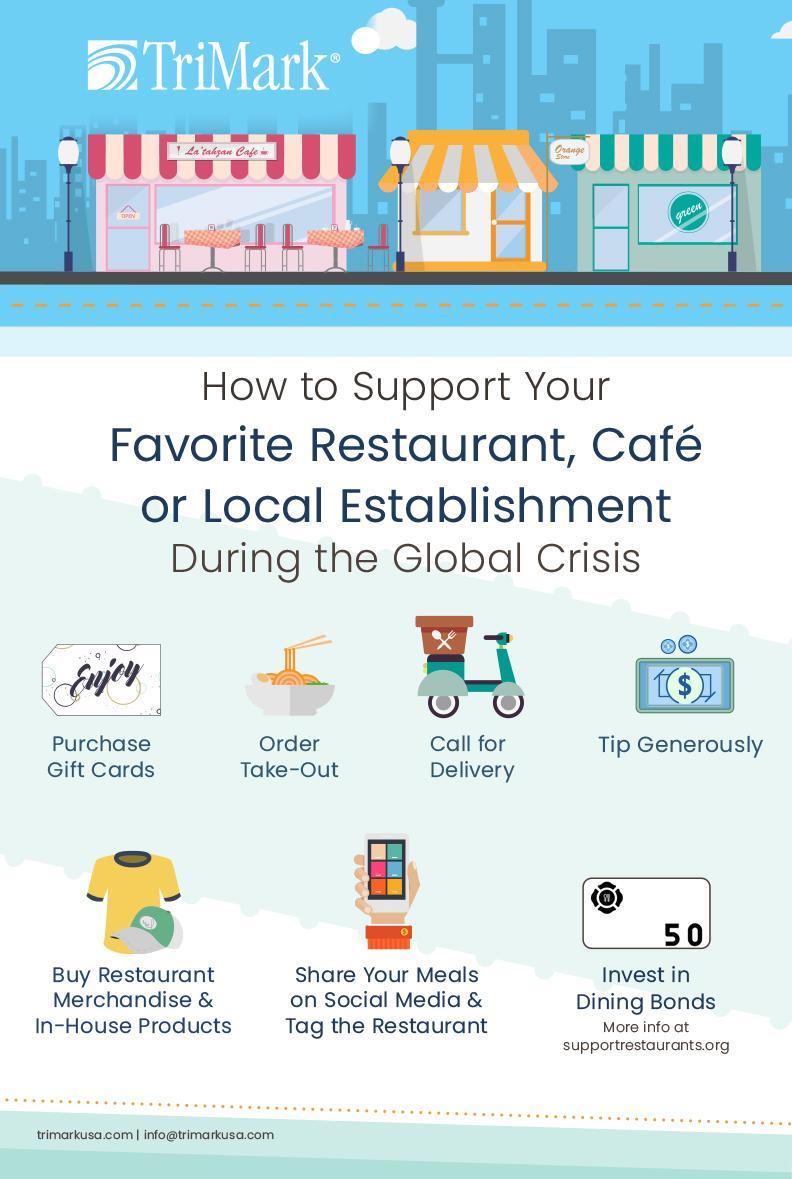Identify some key points in this picture. The image contains the number 50, which represents the last method in the sequence, It is mentioned that there are 7 methods of supporting. The image of a bowl of food represents the method of order take-out. The image of a scooter is representative of the method that involves transporting goods from one location to another using a motorized vehicle. This method is often referred to as "call for delivery. The fourth method mentioned is called "Tip generously. 